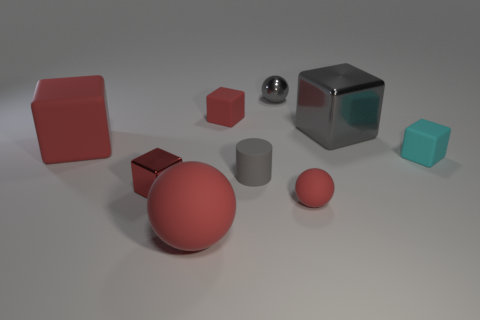Subtract all red blocks. How many were subtracted if there are1red blocks left? 2 Subtract all red spheres. How many red blocks are left? 3 Subtract 1 cubes. How many cubes are left? 4 Subtract all big shiny blocks. How many blocks are left? 4 Subtract all gray blocks. How many blocks are left? 4 Subtract all brown blocks. Subtract all brown spheres. How many blocks are left? 5 Add 1 tiny spheres. How many objects exist? 10 Subtract all cylinders. How many objects are left? 8 Add 4 tiny gray shiny balls. How many tiny gray shiny balls are left? 5 Add 3 small red matte spheres. How many small red matte spheres exist? 4 